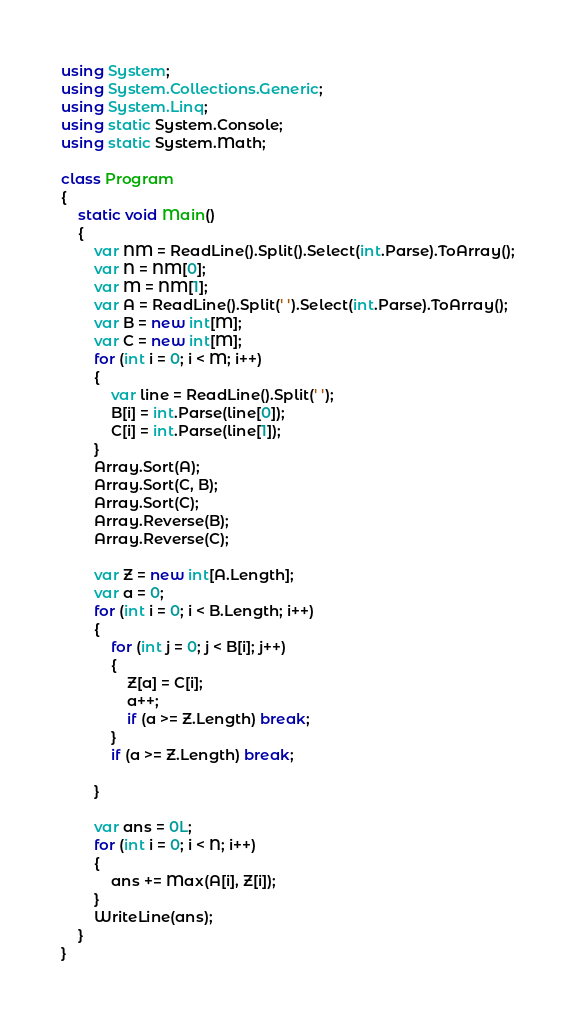Convert code to text. <code><loc_0><loc_0><loc_500><loc_500><_C#_>using System;
using System.Collections.Generic;
using System.Linq;
using static System.Console;
using static System.Math;

class Program
{
    static void Main()
    {
        var NM = ReadLine().Split().Select(int.Parse).ToArray();
        var N = NM[0];
        var M = NM[1];
        var A = ReadLine().Split(' ').Select(int.Parse).ToArray();
        var B = new int[M];
        var C = new int[M];
        for (int i = 0; i < M; i++)
        {
            var line = ReadLine().Split(' ');
            B[i] = int.Parse(line[0]);
            C[i] = int.Parse(line[1]);
        }
        Array.Sort(A);
        Array.Sort(C, B);
        Array.Sort(C);
        Array.Reverse(B);
        Array.Reverse(C);

        var Z = new int[A.Length];
        var a = 0;
        for (int i = 0; i < B.Length; i++)
        {
            for (int j = 0; j < B[i]; j++)
            {
                Z[a] = C[i];
                a++;
                if (a >= Z.Length) break;
            }
            if (a >= Z.Length) break;

        }

        var ans = 0L;
        for (int i = 0; i < N; i++)
        {
            ans += Max(A[i], Z[i]);
        }
        WriteLine(ans);
    }
}
</code> 